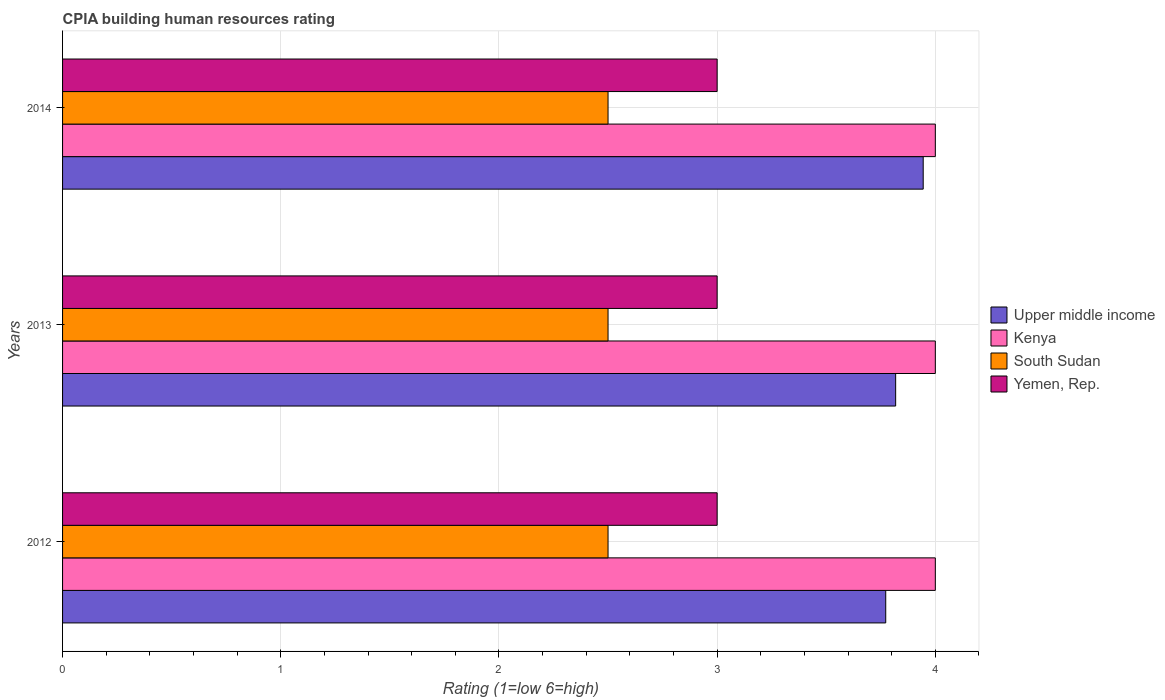How many different coloured bars are there?
Keep it short and to the point. 4. Are the number of bars per tick equal to the number of legend labels?
Give a very brief answer. Yes. How many bars are there on the 3rd tick from the top?
Keep it short and to the point. 4. How many bars are there on the 3rd tick from the bottom?
Keep it short and to the point. 4. What is the CPIA rating in Upper middle income in 2013?
Offer a terse response. 3.82. Across all years, what is the minimum CPIA rating in Kenya?
Keep it short and to the point. 4. What is the total CPIA rating in Upper middle income in the graph?
Make the answer very short. 11.54. What is the difference between the CPIA rating in Kenya in 2014 and the CPIA rating in Upper middle income in 2012?
Your answer should be very brief. 0.23. What is the average CPIA rating in South Sudan per year?
Offer a very short reply. 2.5. In the year 2012, what is the difference between the CPIA rating in South Sudan and CPIA rating in Kenya?
Make the answer very short. -1.5. In how many years, is the CPIA rating in Kenya greater than 2.6 ?
Make the answer very short. 3. What is the ratio of the CPIA rating in South Sudan in 2012 to that in 2014?
Provide a succinct answer. 1. Is the difference between the CPIA rating in South Sudan in 2012 and 2013 greater than the difference between the CPIA rating in Kenya in 2012 and 2013?
Offer a terse response. No. What is the difference between the highest and the lowest CPIA rating in South Sudan?
Offer a terse response. 0. In how many years, is the CPIA rating in Yemen, Rep. greater than the average CPIA rating in Yemen, Rep. taken over all years?
Give a very brief answer. 0. Is the sum of the CPIA rating in South Sudan in 2013 and 2014 greater than the maximum CPIA rating in Yemen, Rep. across all years?
Your answer should be very brief. Yes. Is it the case that in every year, the sum of the CPIA rating in Upper middle income and CPIA rating in Kenya is greater than the sum of CPIA rating in Yemen, Rep. and CPIA rating in South Sudan?
Keep it short and to the point. No. What does the 1st bar from the top in 2013 represents?
Provide a succinct answer. Yemen, Rep. What does the 3rd bar from the bottom in 2014 represents?
Provide a succinct answer. South Sudan. How many bars are there?
Offer a terse response. 12. Are the values on the major ticks of X-axis written in scientific E-notation?
Provide a short and direct response. No. Does the graph contain any zero values?
Offer a very short reply. No. What is the title of the graph?
Ensure brevity in your answer.  CPIA building human resources rating. Does "Chile" appear as one of the legend labels in the graph?
Your answer should be compact. No. What is the label or title of the X-axis?
Your answer should be very brief. Rating (1=low 6=high). What is the label or title of the Y-axis?
Your answer should be compact. Years. What is the Rating (1=low 6=high) of Upper middle income in 2012?
Provide a succinct answer. 3.77. What is the Rating (1=low 6=high) of Yemen, Rep. in 2012?
Provide a short and direct response. 3. What is the Rating (1=low 6=high) of Upper middle income in 2013?
Your answer should be very brief. 3.82. What is the Rating (1=low 6=high) of South Sudan in 2013?
Your answer should be very brief. 2.5. What is the Rating (1=low 6=high) of Yemen, Rep. in 2013?
Your response must be concise. 3. What is the Rating (1=low 6=high) of Upper middle income in 2014?
Provide a succinct answer. 3.94. What is the Rating (1=low 6=high) in South Sudan in 2014?
Provide a short and direct response. 2.5. Across all years, what is the maximum Rating (1=low 6=high) in Upper middle income?
Provide a short and direct response. 3.94. Across all years, what is the maximum Rating (1=low 6=high) of Kenya?
Offer a terse response. 4. Across all years, what is the maximum Rating (1=low 6=high) in South Sudan?
Your response must be concise. 2.5. Across all years, what is the minimum Rating (1=low 6=high) of Upper middle income?
Your answer should be compact. 3.77. Across all years, what is the minimum Rating (1=low 6=high) of Kenya?
Make the answer very short. 4. Across all years, what is the minimum Rating (1=low 6=high) of Yemen, Rep.?
Ensure brevity in your answer.  3. What is the total Rating (1=low 6=high) of Upper middle income in the graph?
Provide a succinct answer. 11.54. What is the total Rating (1=low 6=high) of Kenya in the graph?
Offer a terse response. 12. What is the total Rating (1=low 6=high) in South Sudan in the graph?
Ensure brevity in your answer.  7.5. What is the total Rating (1=low 6=high) in Yemen, Rep. in the graph?
Your response must be concise. 9. What is the difference between the Rating (1=low 6=high) in Upper middle income in 2012 and that in 2013?
Provide a succinct answer. -0.05. What is the difference between the Rating (1=low 6=high) in Yemen, Rep. in 2012 and that in 2013?
Your response must be concise. 0. What is the difference between the Rating (1=low 6=high) in Upper middle income in 2012 and that in 2014?
Offer a very short reply. -0.17. What is the difference between the Rating (1=low 6=high) of Kenya in 2012 and that in 2014?
Give a very brief answer. 0. What is the difference between the Rating (1=low 6=high) in South Sudan in 2012 and that in 2014?
Offer a very short reply. 0. What is the difference between the Rating (1=low 6=high) in Yemen, Rep. in 2012 and that in 2014?
Ensure brevity in your answer.  0. What is the difference between the Rating (1=low 6=high) of Upper middle income in 2013 and that in 2014?
Your response must be concise. -0.13. What is the difference between the Rating (1=low 6=high) in Kenya in 2013 and that in 2014?
Your answer should be compact. 0. What is the difference between the Rating (1=low 6=high) of Yemen, Rep. in 2013 and that in 2014?
Offer a terse response. 0. What is the difference between the Rating (1=low 6=high) in Upper middle income in 2012 and the Rating (1=low 6=high) in Kenya in 2013?
Make the answer very short. -0.23. What is the difference between the Rating (1=low 6=high) of Upper middle income in 2012 and the Rating (1=low 6=high) of South Sudan in 2013?
Offer a very short reply. 1.27. What is the difference between the Rating (1=low 6=high) in Upper middle income in 2012 and the Rating (1=low 6=high) in Yemen, Rep. in 2013?
Make the answer very short. 0.77. What is the difference between the Rating (1=low 6=high) of Kenya in 2012 and the Rating (1=low 6=high) of South Sudan in 2013?
Offer a terse response. 1.5. What is the difference between the Rating (1=low 6=high) of Upper middle income in 2012 and the Rating (1=low 6=high) of Kenya in 2014?
Your response must be concise. -0.23. What is the difference between the Rating (1=low 6=high) of Upper middle income in 2012 and the Rating (1=low 6=high) of South Sudan in 2014?
Offer a very short reply. 1.27. What is the difference between the Rating (1=low 6=high) in Upper middle income in 2012 and the Rating (1=low 6=high) in Yemen, Rep. in 2014?
Your answer should be compact. 0.77. What is the difference between the Rating (1=low 6=high) in Kenya in 2012 and the Rating (1=low 6=high) in South Sudan in 2014?
Ensure brevity in your answer.  1.5. What is the difference between the Rating (1=low 6=high) of Upper middle income in 2013 and the Rating (1=low 6=high) of Kenya in 2014?
Ensure brevity in your answer.  -0.18. What is the difference between the Rating (1=low 6=high) of Upper middle income in 2013 and the Rating (1=low 6=high) of South Sudan in 2014?
Your answer should be very brief. 1.32. What is the difference between the Rating (1=low 6=high) of Upper middle income in 2013 and the Rating (1=low 6=high) of Yemen, Rep. in 2014?
Your answer should be compact. 0.82. What is the difference between the Rating (1=low 6=high) in South Sudan in 2013 and the Rating (1=low 6=high) in Yemen, Rep. in 2014?
Your answer should be very brief. -0.5. What is the average Rating (1=low 6=high) of Upper middle income per year?
Your response must be concise. 3.85. What is the average Rating (1=low 6=high) of Kenya per year?
Your response must be concise. 4. In the year 2012, what is the difference between the Rating (1=low 6=high) in Upper middle income and Rating (1=low 6=high) in Kenya?
Provide a short and direct response. -0.23. In the year 2012, what is the difference between the Rating (1=low 6=high) in Upper middle income and Rating (1=low 6=high) in South Sudan?
Provide a succinct answer. 1.27. In the year 2012, what is the difference between the Rating (1=low 6=high) of Upper middle income and Rating (1=low 6=high) of Yemen, Rep.?
Your answer should be compact. 0.77. In the year 2012, what is the difference between the Rating (1=low 6=high) of Kenya and Rating (1=low 6=high) of South Sudan?
Give a very brief answer. 1.5. In the year 2012, what is the difference between the Rating (1=low 6=high) in Kenya and Rating (1=low 6=high) in Yemen, Rep.?
Offer a very short reply. 1. In the year 2013, what is the difference between the Rating (1=low 6=high) in Upper middle income and Rating (1=low 6=high) in Kenya?
Offer a very short reply. -0.18. In the year 2013, what is the difference between the Rating (1=low 6=high) of Upper middle income and Rating (1=low 6=high) of South Sudan?
Offer a very short reply. 1.32. In the year 2013, what is the difference between the Rating (1=low 6=high) in Upper middle income and Rating (1=low 6=high) in Yemen, Rep.?
Your response must be concise. 0.82. In the year 2013, what is the difference between the Rating (1=low 6=high) of Kenya and Rating (1=low 6=high) of South Sudan?
Give a very brief answer. 1.5. In the year 2014, what is the difference between the Rating (1=low 6=high) of Upper middle income and Rating (1=low 6=high) of Kenya?
Your answer should be compact. -0.06. In the year 2014, what is the difference between the Rating (1=low 6=high) of Upper middle income and Rating (1=low 6=high) of South Sudan?
Make the answer very short. 1.44. In the year 2014, what is the difference between the Rating (1=low 6=high) of Upper middle income and Rating (1=low 6=high) of Yemen, Rep.?
Provide a succinct answer. 0.94. What is the ratio of the Rating (1=low 6=high) of Upper middle income in 2012 to that in 2013?
Your response must be concise. 0.99. What is the ratio of the Rating (1=low 6=high) of Kenya in 2012 to that in 2013?
Keep it short and to the point. 1. What is the ratio of the Rating (1=low 6=high) in Upper middle income in 2012 to that in 2014?
Make the answer very short. 0.96. What is the ratio of the Rating (1=low 6=high) in South Sudan in 2012 to that in 2014?
Your answer should be compact. 1. What is the ratio of the Rating (1=low 6=high) of Yemen, Rep. in 2012 to that in 2014?
Give a very brief answer. 1. What is the difference between the highest and the second highest Rating (1=low 6=high) of Upper middle income?
Provide a short and direct response. 0.13. What is the difference between the highest and the lowest Rating (1=low 6=high) of Upper middle income?
Ensure brevity in your answer.  0.17. What is the difference between the highest and the lowest Rating (1=low 6=high) in Yemen, Rep.?
Your response must be concise. 0. 